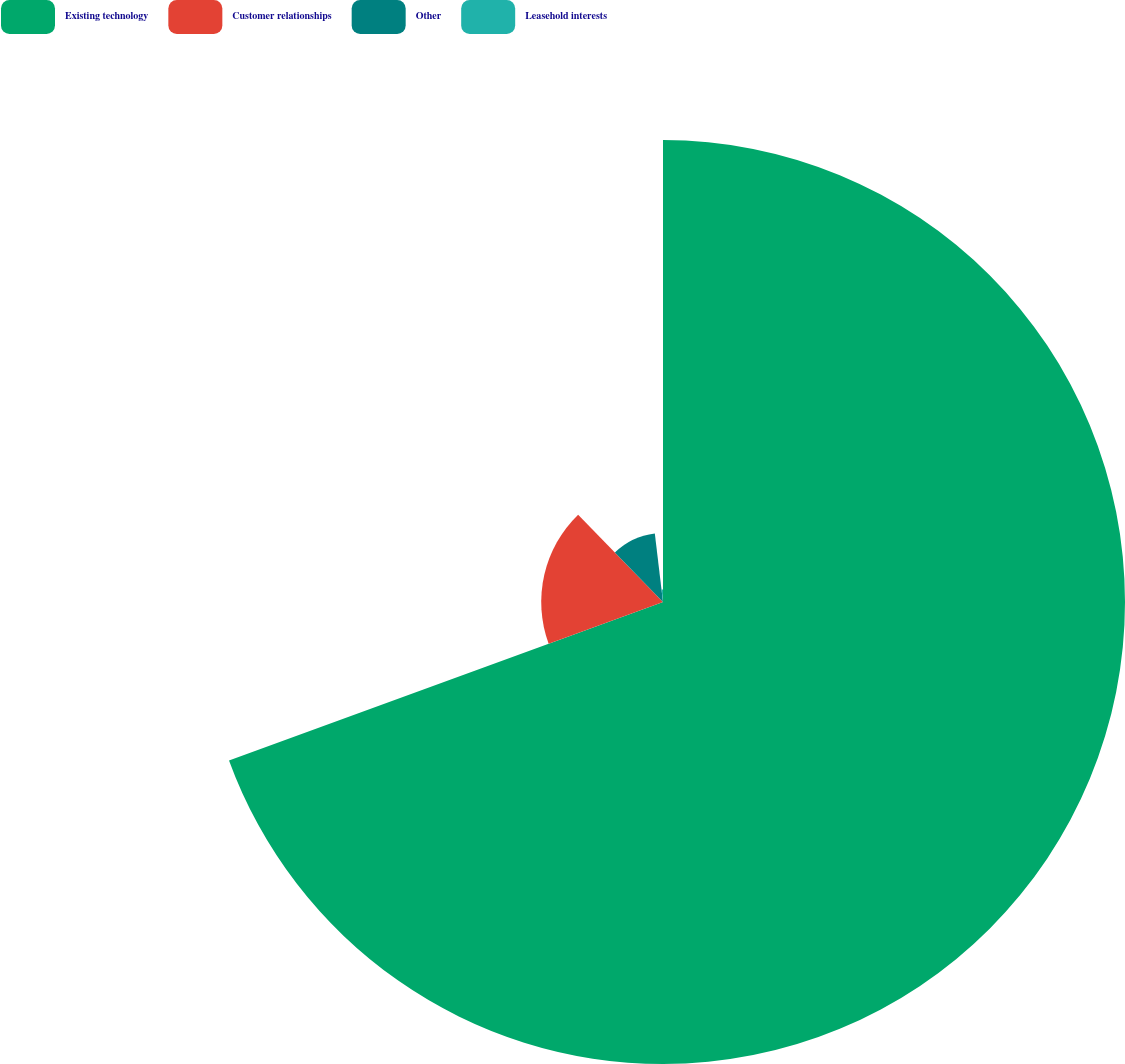Convert chart. <chart><loc_0><loc_0><loc_500><loc_500><pie_chart><fcel>Existing technology<fcel>Customer relationships<fcel>Other<fcel>Leasehold interests<nl><fcel>69.43%<fcel>18.3%<fcel>10.38%<fcel>1.89%<nl></chart> 